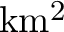Convert formula to latex. <formula><loc_0><loc_0><loc_500><loc_500>k m ^ { 2 }</formula> 